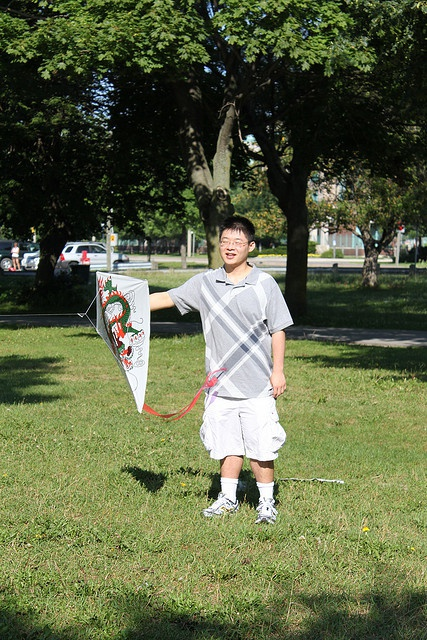Describe the objects in this image and their specific colors. I can see people in black, lightgray, darkgray, and tan tones, kite in black, white, darkgray, darkgreen, and gray tones, car in black, lightgray, darkgray, and gray tones, car in black, gray, navy, and purple tones, and car in black, white, darkgray, and gray tones in this image. 